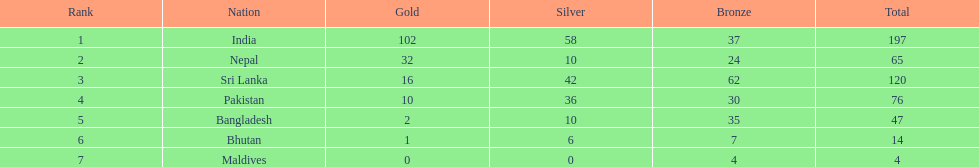Help me parse the entirety of this table. {'header': ['Rank', 'Nation', 'Gold', 'Silver', 'Bronze', 'Total'], 'rows': [['1', 'India', '102', '58', '37', '197'], ['2', 'Nepal', '32', '10', '24', '65'], ['3', 'Sri Lanka', '16', '42', '62', '120'], ['4', 'Pakistan', '10', '36', '30', '76'], ['5', 'Bangladesh', '2', '10', '35', '47'], ['6', 'Bhutan', '1', '6', '7', '14'], ['7', 'Maldives', '0', '0', '4', '4']]} What is the variation between the nation with the greatest quantity of medals and the nation with the least quantity of medals? 193. 